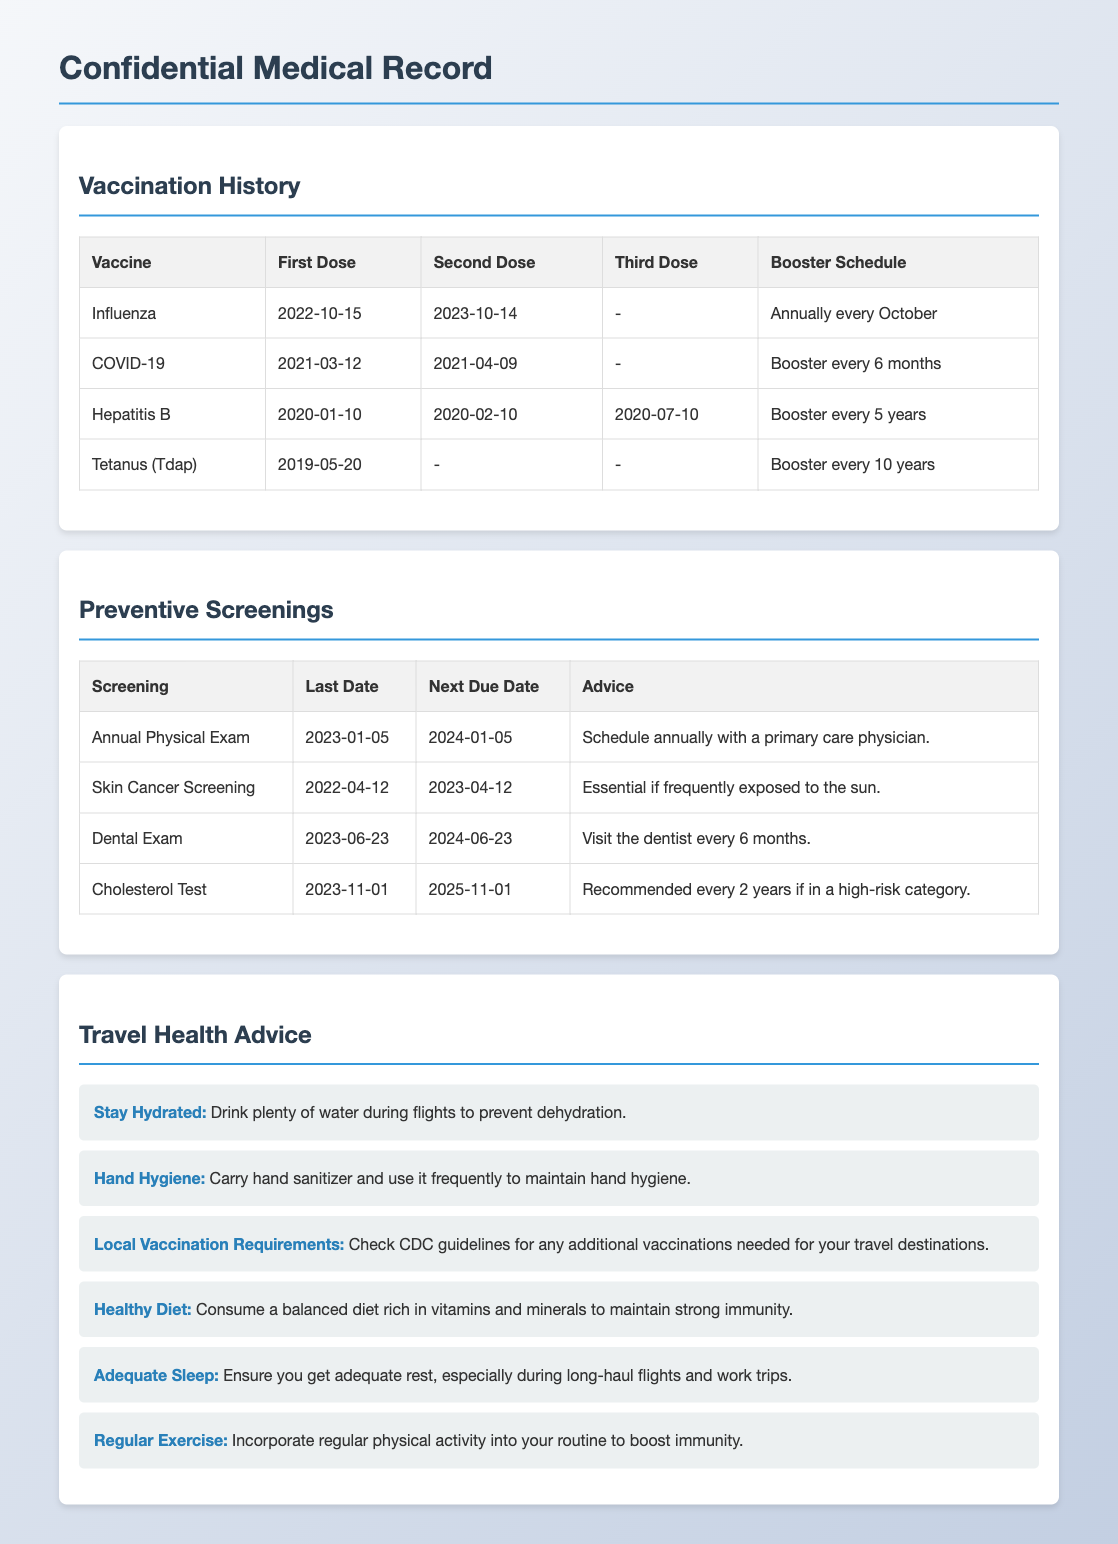What is the first dose date for the Influenza vaccine? The first dose date for the Influenza vaccine is listed in the vaccination history section.
Answer: 2022-10-15 What is the booster schedule for Hepatitis B? The booster schedule for Hepatitis B is mentioned in the vaccination table.
Answer: Booster every 5 years When is the next due date for the Annual Physical Exam? The next due date for the Annual Physical Exam is found in the preventive screenings section.
Answer: 2024-01-05 How often should a dental exam be scheduled? The frequency of dental exams is indicated in the preventive screenings table.
Answer: Every 6 months What advice is given for maintaining hydration during travel? The travel health advice section provides specific health advice during travel.
Answer: Drink plenty of water during flights What is recommended if someone is frequently exposed to the sun? This recommendation is based on the preventive screenings information.
Answer: Skin Cancer Screening How many vaccines are listed in the vaccination history section? The number of vaccines can be counted from the vaccination history table.
Answer: Four What health practice is emphasized for boosting immunity? This practice is a part of the travel health advice provided in the document.
Answer: Regular Exercise What is the last date for the Cholesterol Test? The last date is specified in the preventive screenings table.
Answer: 2023-11-01 